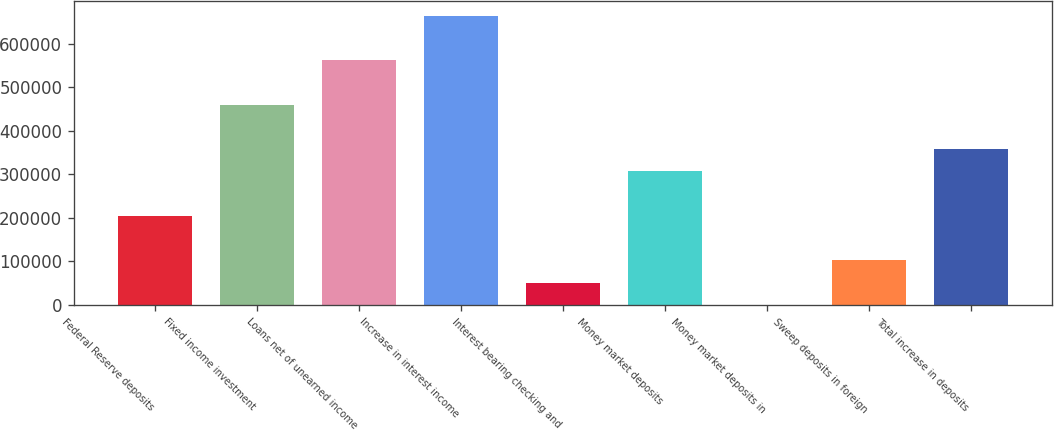Convert chart. <chart><loc_0><loc_0><loc_500><loc_500><bar_chart><fcel>Federal Reserve deposits<fcel>Fixed income investment<fcel>Loans net of unearned income<fcel>Increase in interest income<fcel>Interest bearing checking and<fcel>Money market deposits<fcel>Money market deposits in<fcel>Sweep deposits in foreign<fcel>Total increase in deposits<nl><fcel>204362<fcel>459805<fcel>561983<fcel>664160<fcel>51096.6<fcel>306540<fcel>8<fcel>102185<fcel>357628<nl></chart> 